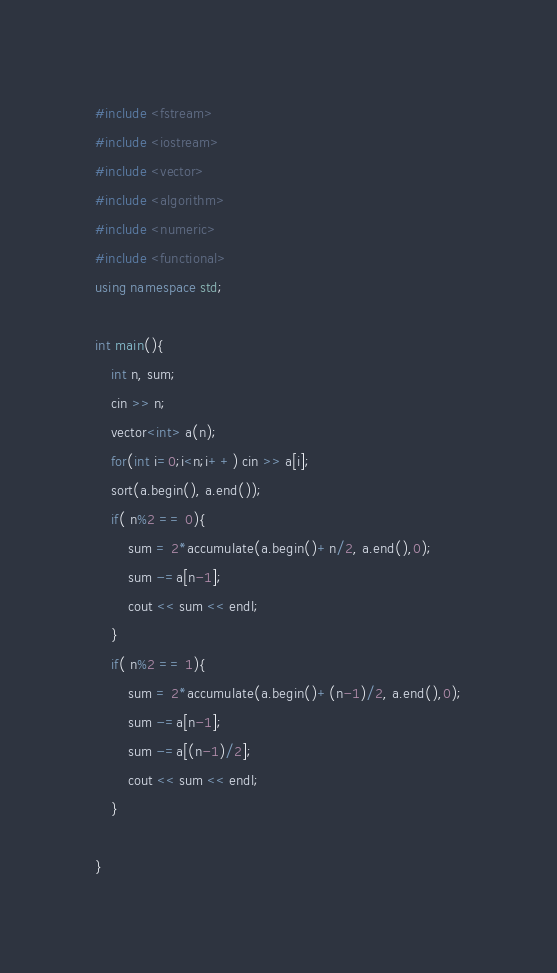<code> <loc_0><loc_0><loc_500><loc_500><_C++_>#include <fstream>
#include <iostream>
#include <vector>
#include <algorithm>
#include <numeric>
#include <functional>
using namespace std;

int main(){
    int n, sum;
    cin >> n;
    vector<int> a(n);
    for(int i=0;i<n;i++) cin >> a[i];
    sort(a.begin(), a.end());
    if( n%2 == 0){
        sum = 2*accumulate(a.begin()+n/2, a.end(),0);
        sum -=a[n-1];
        cout << sum << endl;
    }
    if( n%2 == 1){
        sum = 2*accumulate(a.begin()+(n-1)/2, a.end(),0);
        sum -=a[n-1];
        sum -=a[(n-1)/2];
        cout << sum << endl;
    }

}</code> 